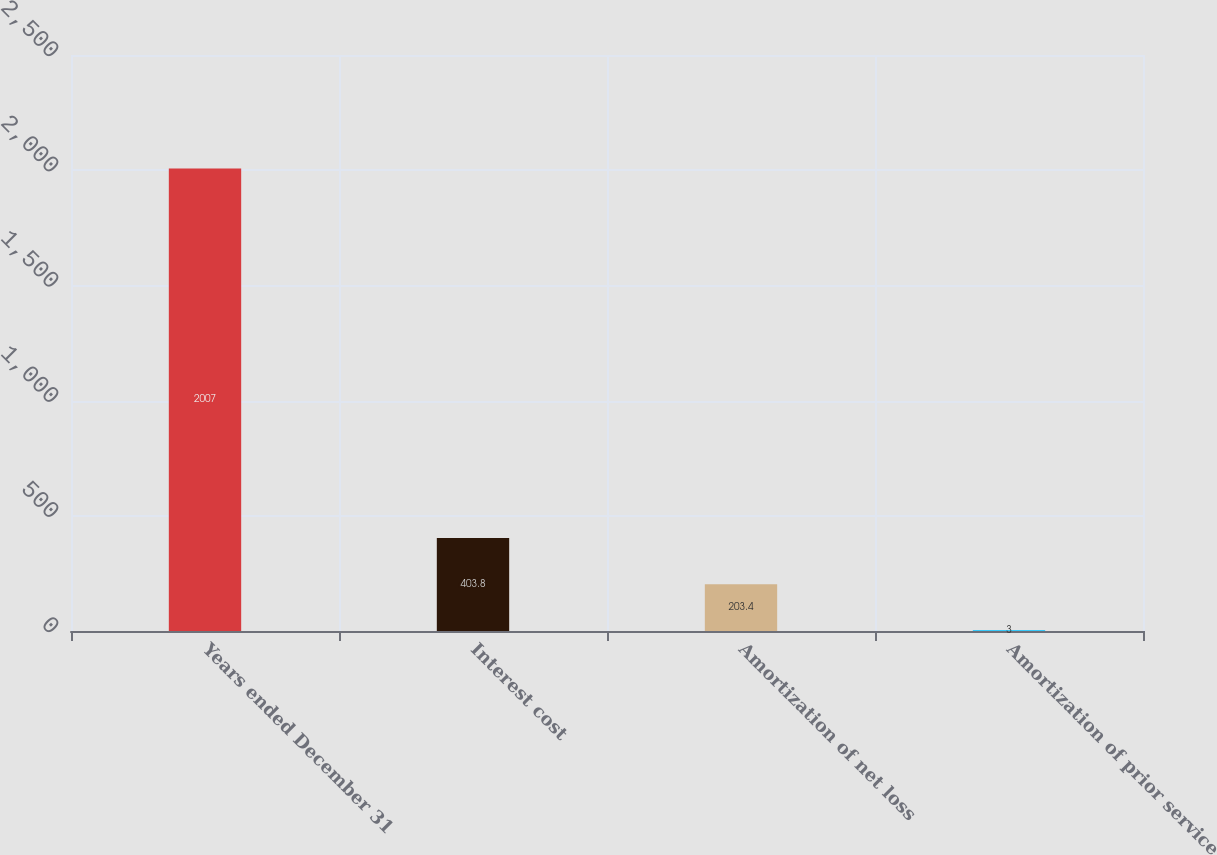Convert chart. <chart><loc_0><loc_0><loc_500><loc_500><bar_chart><fcel>Years ended December 31<fcel>Interest cost<fcel>Amortization of net loss<fcel>Amortization of prior service<nl><fcel>2007<fcel>403.8<fcel>203.4<fcel>3<nl></chart> 